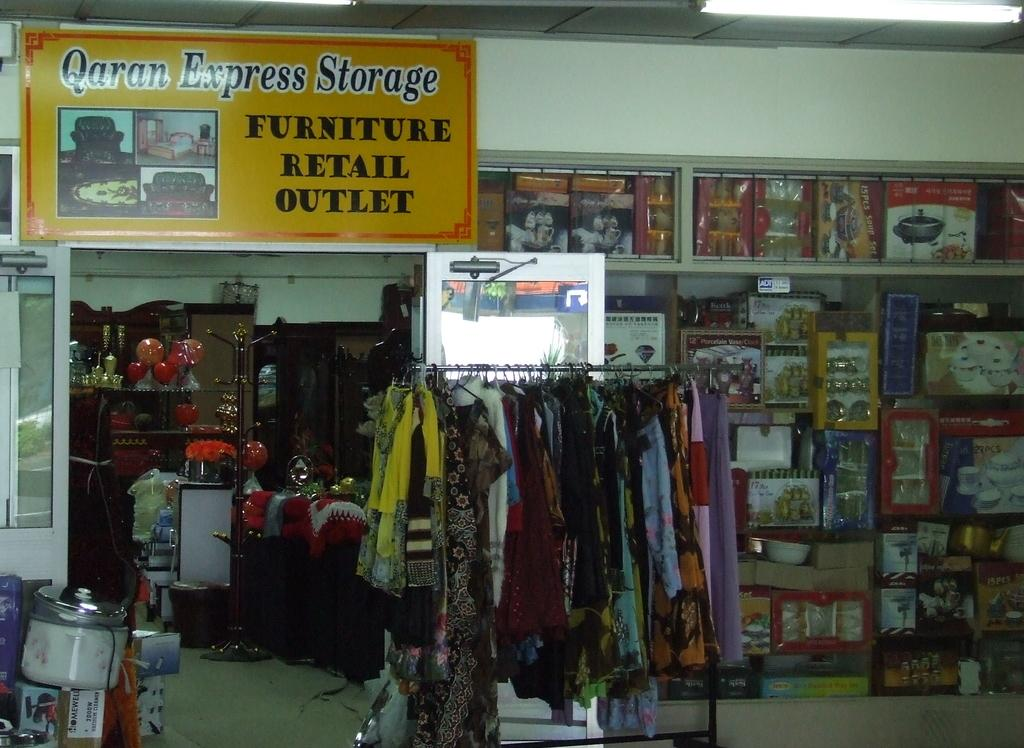<image>
Create a compact narrative representing the image presented. A sales rack in front of a sign Qaran Express Storage. 